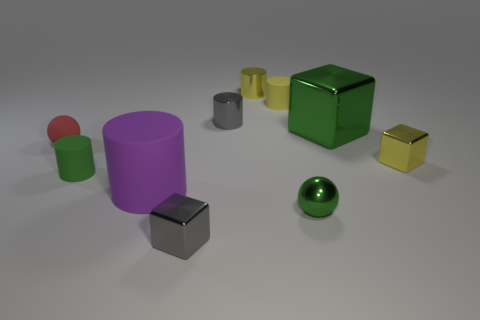What is the size of the sphere in front of the green object to the left of the tiny gray metallic cube?
Ensure brevity in your answer.  Small. What material is the green object that is both right of the gray metal cylinder and left of the green block?
Provide a short and direct response. Metal. What number of other objects are there of the same size as the green block?
Make the answer very short. 1. What is the color of the large shiny cube?
Provide a short and direct response. Green. There is a large thing that is behind the tiny red rubber object; is it the same color as the metallic cylinder that is behind the yellow matte cylinder?
Offer a terse response. No. How big is the green rubber object?
Offer a very short reply. Small. There is a yellow shiny object that is on the right side of the green block; how big is it?
Make the answer very short. Small. What shape is the shiny object that is both behind the tiny matte sphere and on the right side of the shiny ball?
Your answer should be very brief. Cube. What number of other objects are there of the same shape as the large rubber object?
Offer a very short reply. 4. There is another ball that is the same size as the metallic ball; what is its color?
Ensure brevity in your answer.  Red. 